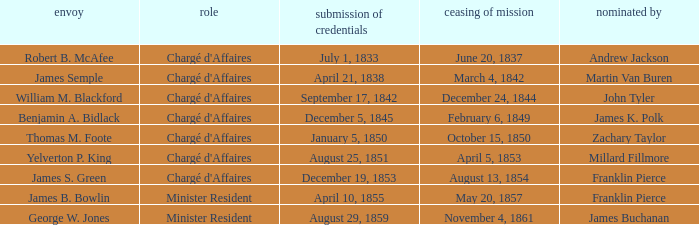What's the Representative listed that has a Presentation of Credentials of August 25, 1851? Yelverton P. King. Write the full table. {'header': ['envoy', 'role', 'submission of credentials', 'ceasing of mission', 'nominated by'], 'rows': [['Robert B. McAfee', "Chargé d'Affaires", 'July 1, 1833', 'June 20, 1837', 'Andrew Jackson'], ['James Semple', "Chargé d'Affaires", 'April 21, 1838', 'March 4, 1842', 'Martin Van Buren'], ['William M. Blackford', "Chargé d'Affaires", 'September 17, 1842', 'December 24, 1844', 'John Tyler'], ['Benjamin A. Bidlack', "Chargé d'Affaires", 'December 5, 1845', 'February 6, 1849', 'James K. Polk'], ['Thomas M. Foote', "Chargé d'Affaires", 'January 5, 1850', 'October 15, 1850', 'Zachary Taylor'], ['Yelverton P. King', "Chargé d'Affaires", 'August 25, 1851', 'April 5, 1853', 'Millard Fillmore'], ['James S. Green', "Chargé d'Affaires", 'December 19, 1853', 'August 13, 1854', 'Franklin Pierce'], ['James B. Bowlin', 'Minister Resident', 'April 10, 1855', 'May 20, 1857', 'Franklin Pierce'], ['George W. Jones', 'Minister Resident', 'August 29, 1859', 'November 4, 1861', 'James Buchanan']]} 